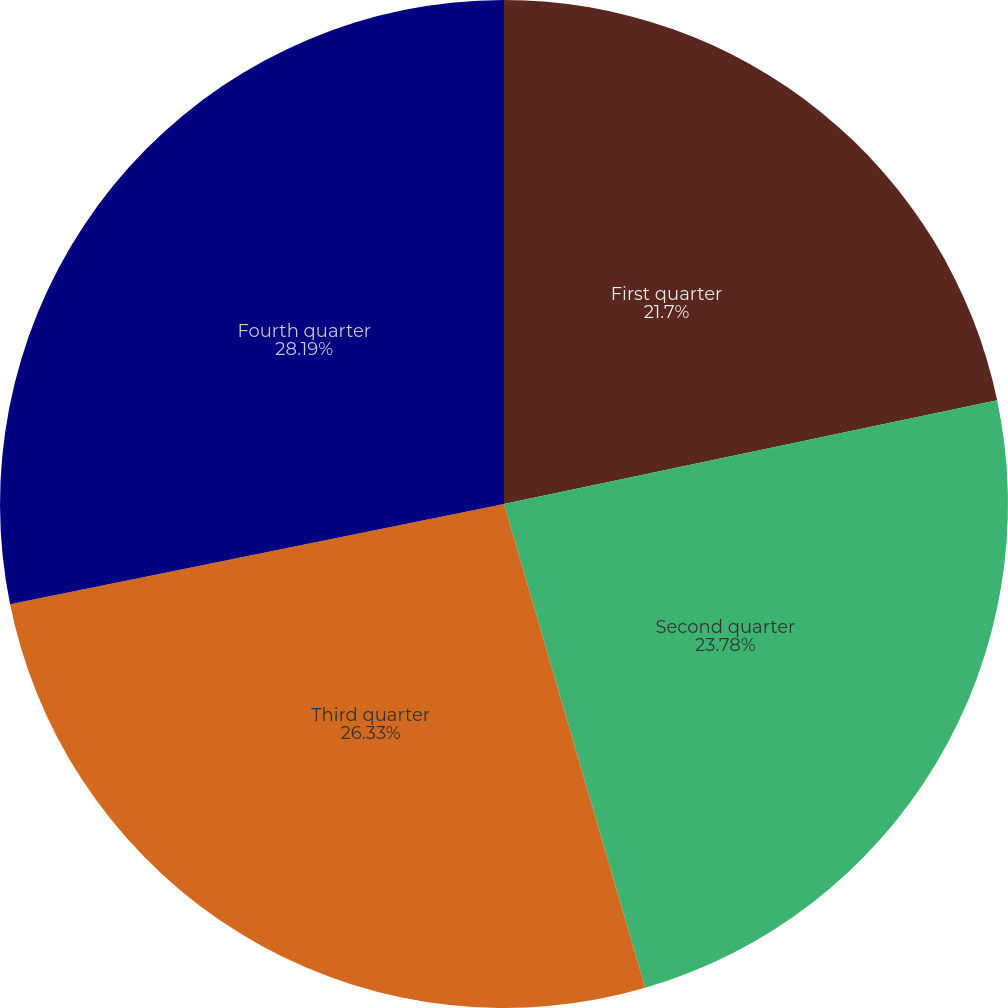Convert chart to OTSL. <chart><loc_0><loc_0><loc_500><loc_500><pie_chart><fcel>First quarter<fcel>Second quarter<fcel>Third quarter<fcel>Fourth quarter<nl><fcel>21.7%<fcel>23.78%<fcel>26.33%<fcel>28.19%<nl></chart> 